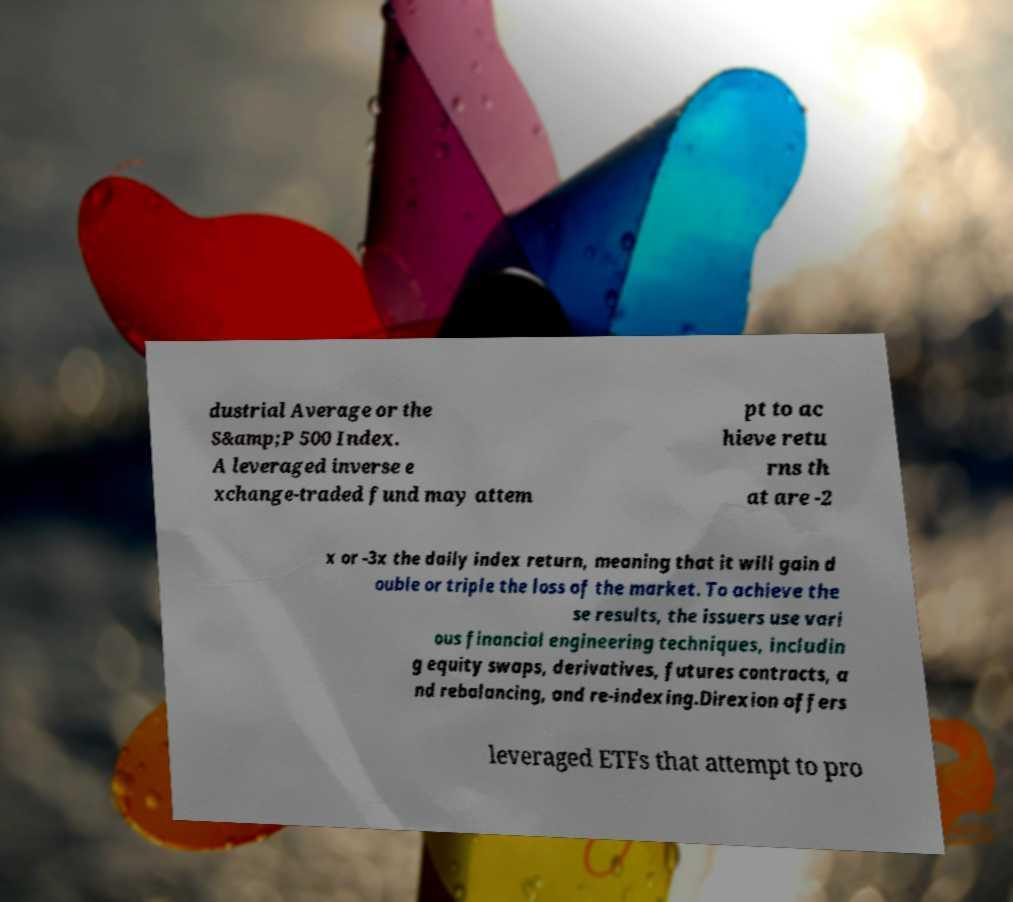Can you accurately transcribe the text from the provided image for me? dustrial Average or the S&amp;P 500 Index. A leveraged inverse e xchange-traded fund may attem pt to ac hieve retu rns th at are -2 x or -3x the daily index return, meaning that it will gain d ouble or triple the loss of the market. To achieve the se results, the issuers use vari ous financial engineering techniques, includin g equity swaps, derivatives, futures contracts, a nd rebalancing, and re-indexing.Direxion offers leveraged ETFs that attempt to pro 